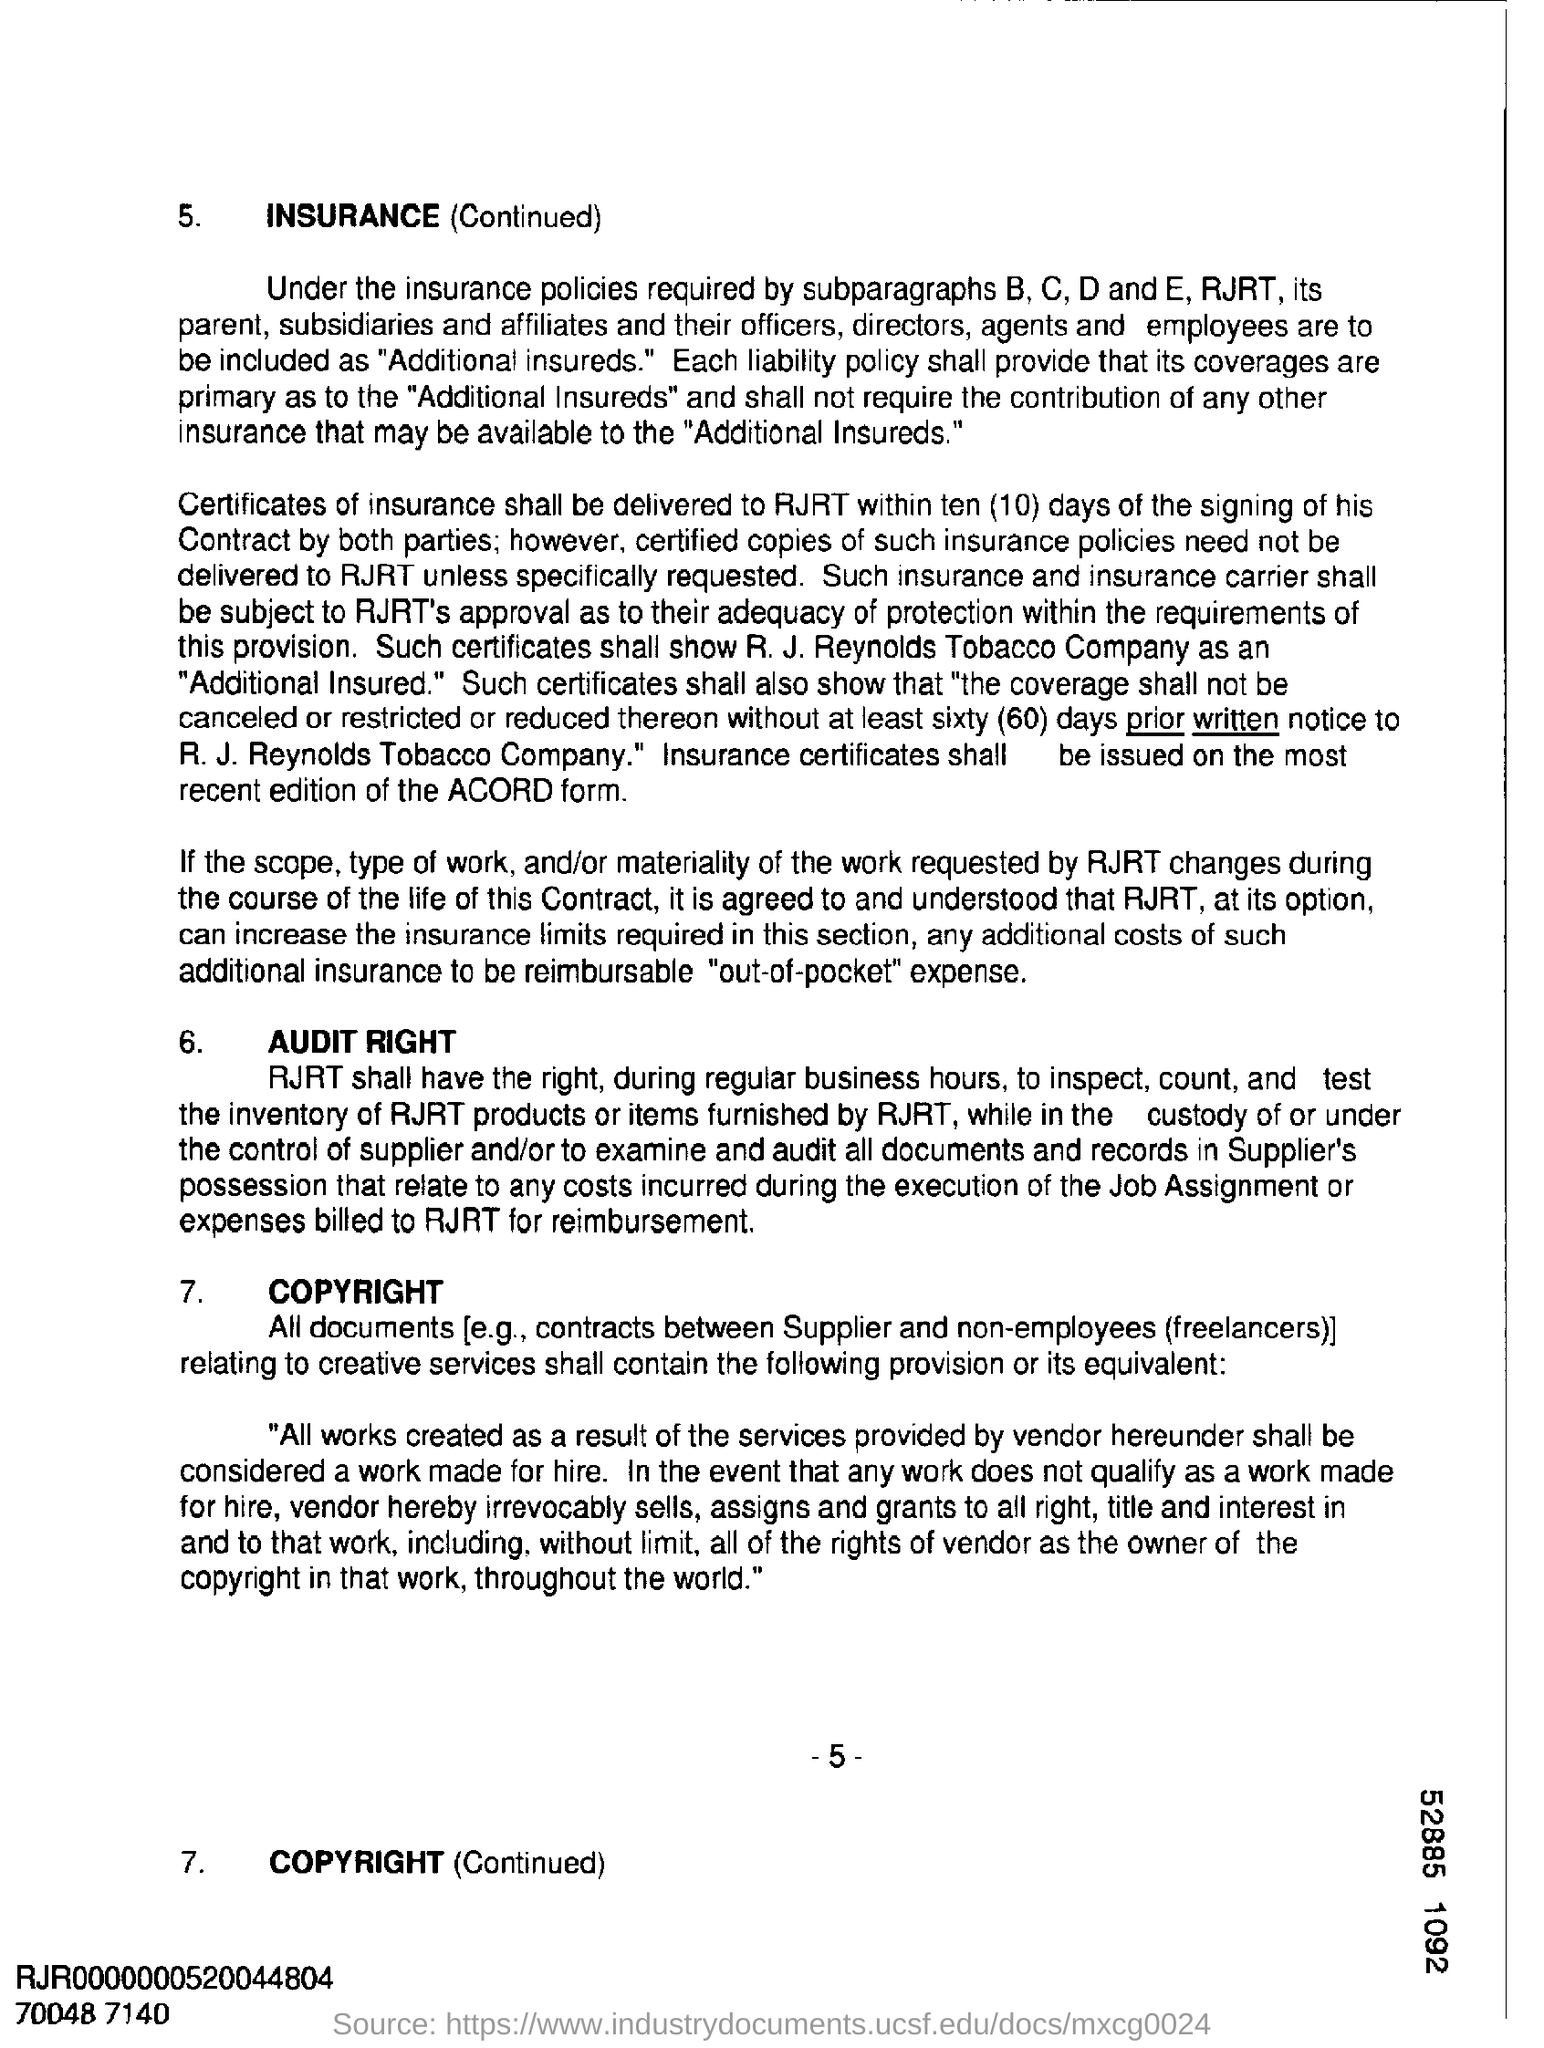Point out several critical features in this image. The page number is 5, with additional pages following. 